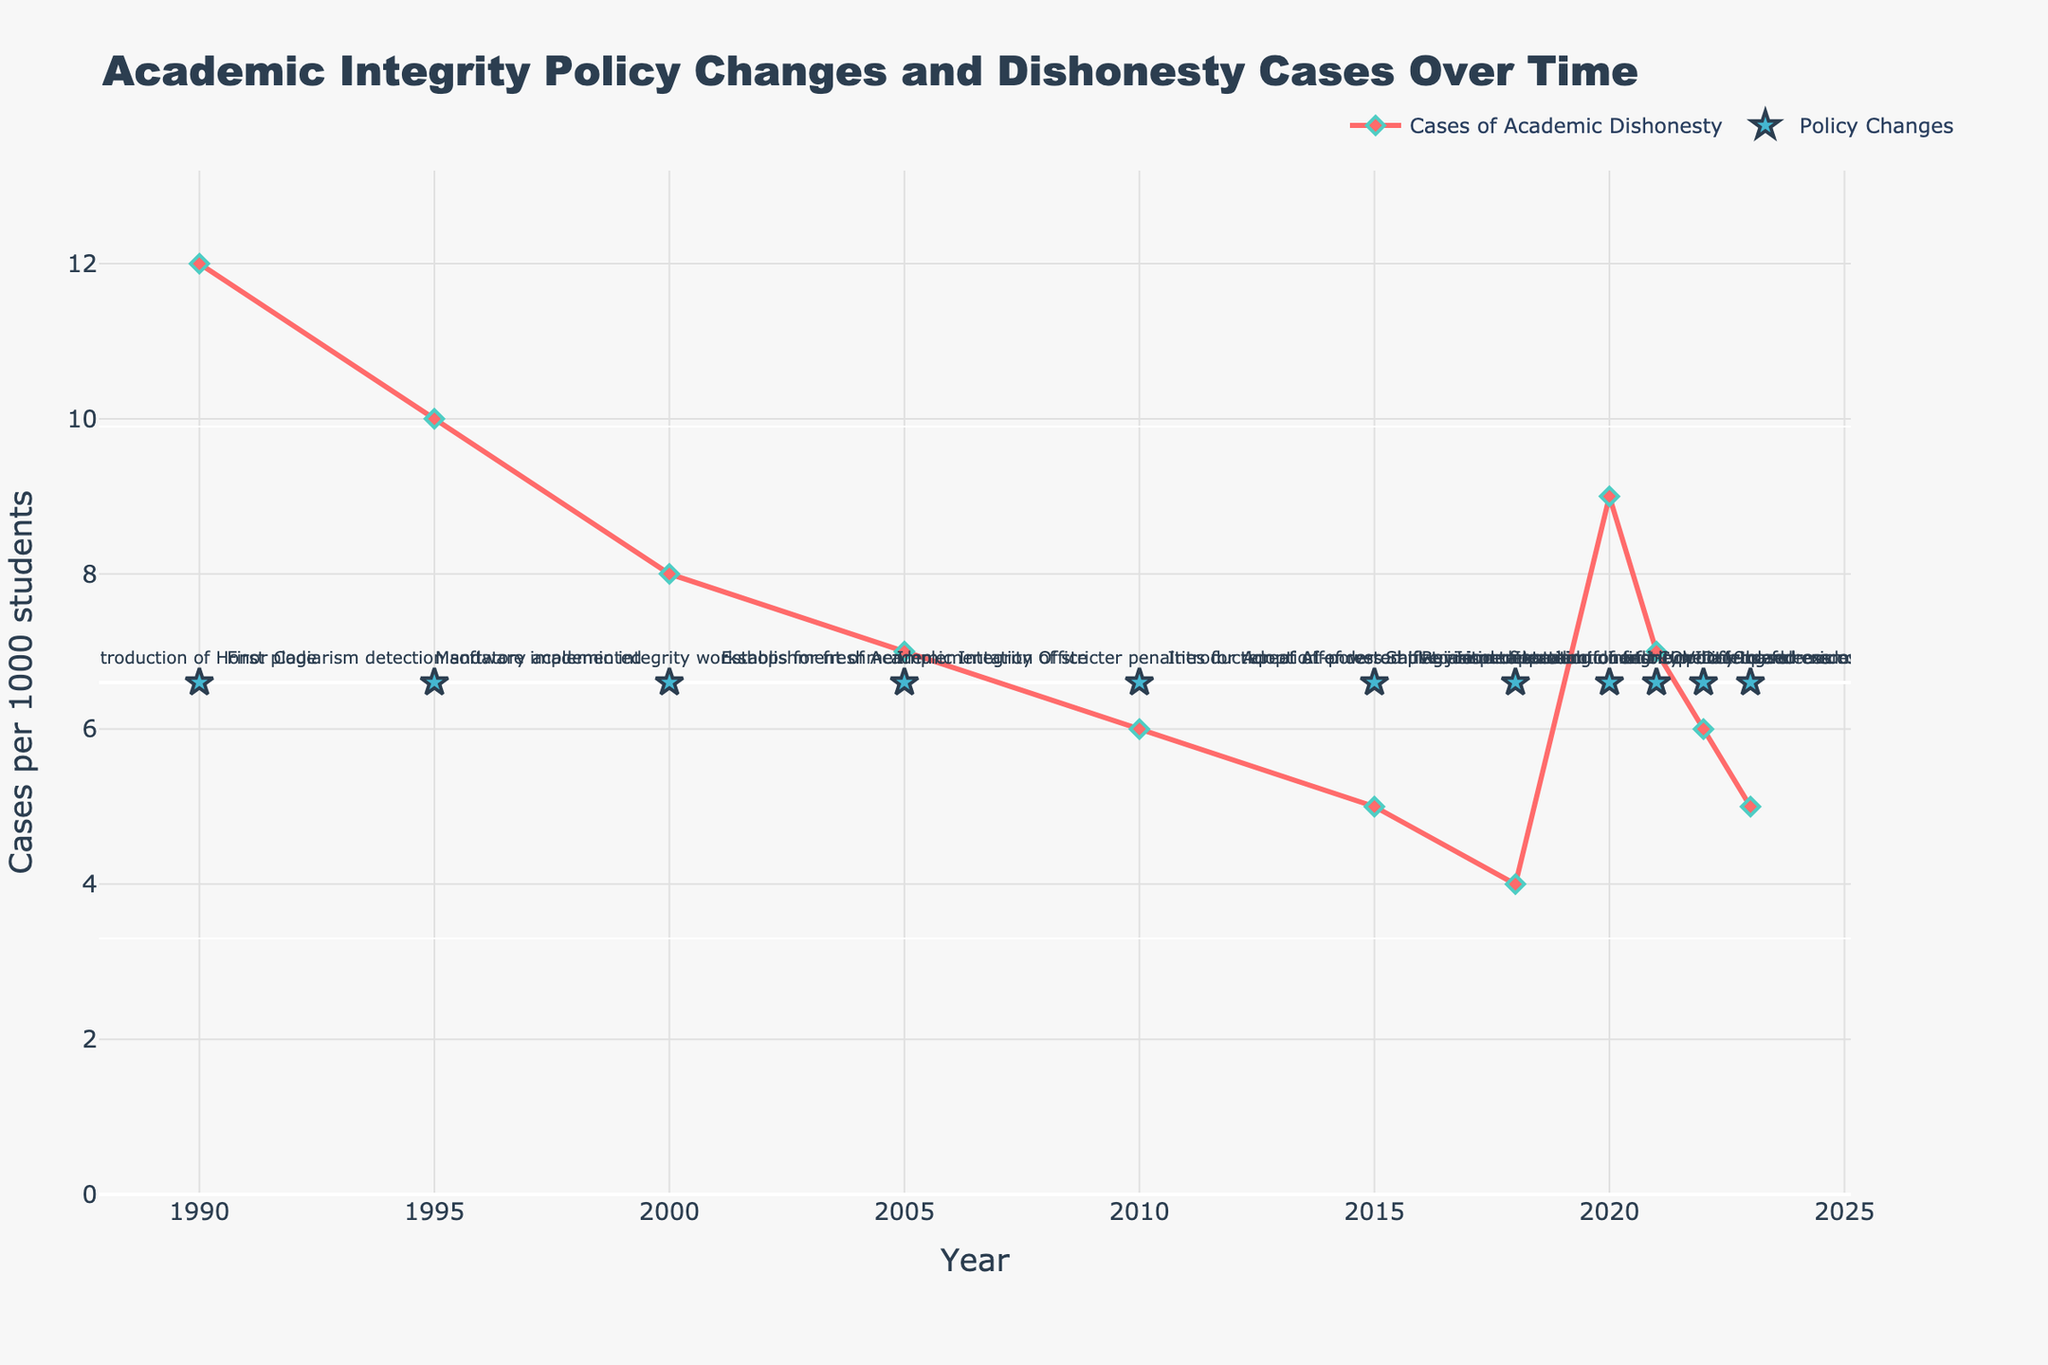What major policy change was introduced in 1990? The figure indicates that the major policy change in 1990 was the introduction of the Honor Code, highlighted by a marker and text at the year 1990.
Answer: Introduction of Honor Code What is the general trend in the cases of academic dishonesty from 1990 to 2015? To identify the general trend, we observe the line representing the cases of academic dishonesty from 1990 to 2015. The cases generally decline from 12 in 1990 to 5 in 2015.
Answer: Declining How did the shift to remote learning due to COVID-19 in 2020 affect the cases of academic dishonesty? The cases increased significantly, from 4 in 2018 to 9 in 2020, which is visible by the sharp rise in the line graph at that point in time.
Answer: Increased Compare the number of academic dishonesty cases before and after the implementation of online proctoring for exams in 2021. The number of cases was 9 in 2020, and it decreased to 7 in 2021, indicating a reduction after the implementation of online proctoring.
Answer: Decreased What was the impact of the introduction of AI-powered plagiarism detection in 2015 on academic dishonesty cases? The cases dropped from 6 in 2010 to 5 in 2015 after the introduction of AI-powered plagiarism detection, shown by a declination in the line graph.
Answer: Decreased How many cases were there in the year when the Academic Integrity Office was established? The establishment of the Academic Integrity Office occurred in 2005, at which the cases of academic dishonesty were 7, as indicated by the line graph next to that year.
Answer: 7 Which year saw the largest single-year decrease in cases, and what was the magnitude of the decrease? The largest single-year decrease occurred from 2020 to 2021, where the cases dropped from 9 to 7, a difference of 2 cases, which is observable from the line graph.
Answer: 2021, drop of 2 cases What policy change occurred simultaneously with the lowest number of academic dishonesty cases on the graph? By examining the figure, the lowest number of cases (4) occurred in 2018, concurrent with the adoption of a restorative justice approach for first-time offenders.
Answer: Adoption of restorative justice approach for first-time offenders How did the implementation of stricter penalties for repeat offenders in 2010 affect academic dishonesty cases by 2015? From 2010 (cases = 6) to 2015 (cases = 5), the number of cases decreased as indicated by the line graph, reflecting the effect of stricter penalties implemented in 2010.
Answer: Decreased 